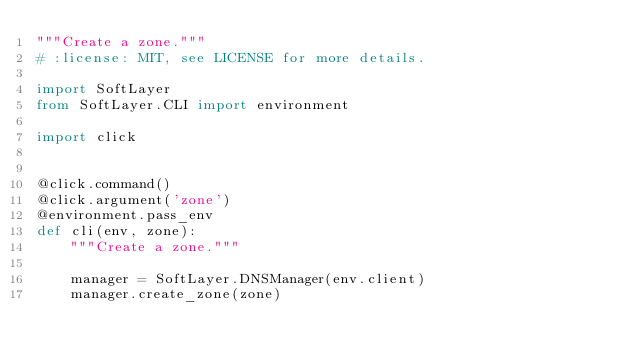Convert code to text. <code><loc_0><loc_0><loc_500><loc_500><_Python_>"""Create a zone."""
# :license: MIT, see LICENSE for more details.

import SoftLayer
from SoftLayer.CLI import environment

import click


@click.command()
@click.argument('zone')
@environment.pass_env
def cli(env, zone):
    """Create a zone."""

    manager = SoftLayer.DNSManager(env.client)
    manager.create_zone(zone)
</code> 